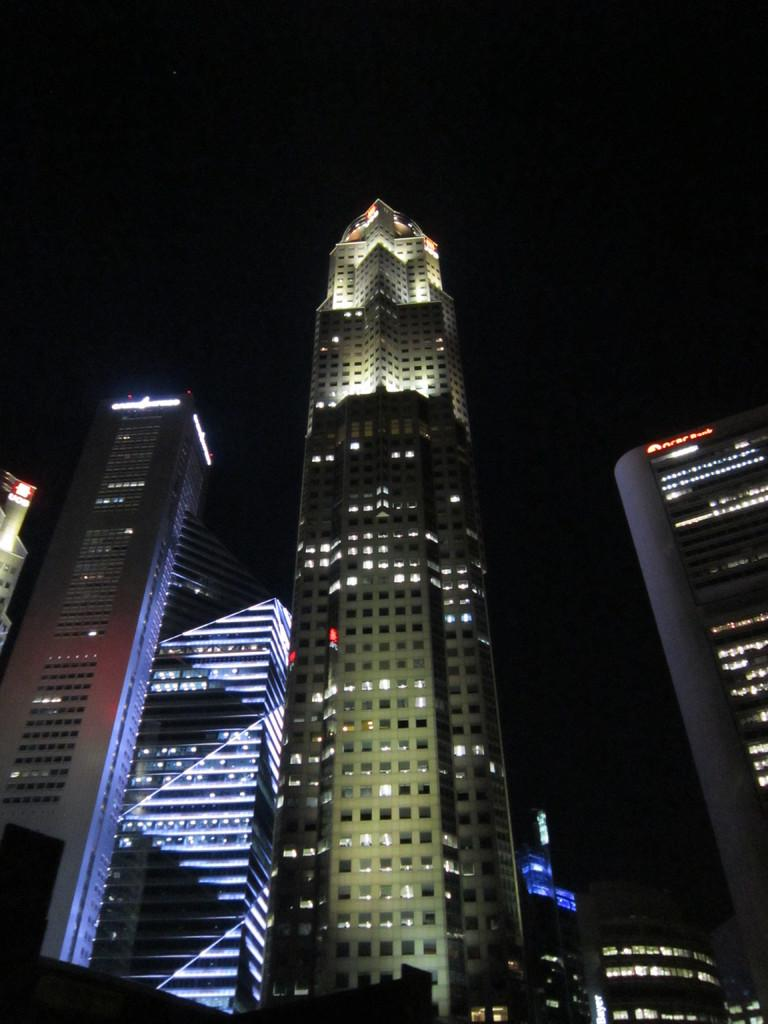What is the perspective of the image? The image shows a view of buildings from the bottom. What can be seen in the sky in the image? The sky is dark in the image. What type of error can be seen in the image? There is no error present in the image; it is a clear view of buildings and a dark sky. Can you see any steam coming from the buildings in the image? There is no steam visible in the image; it only shows the buildings and the dark sky. 